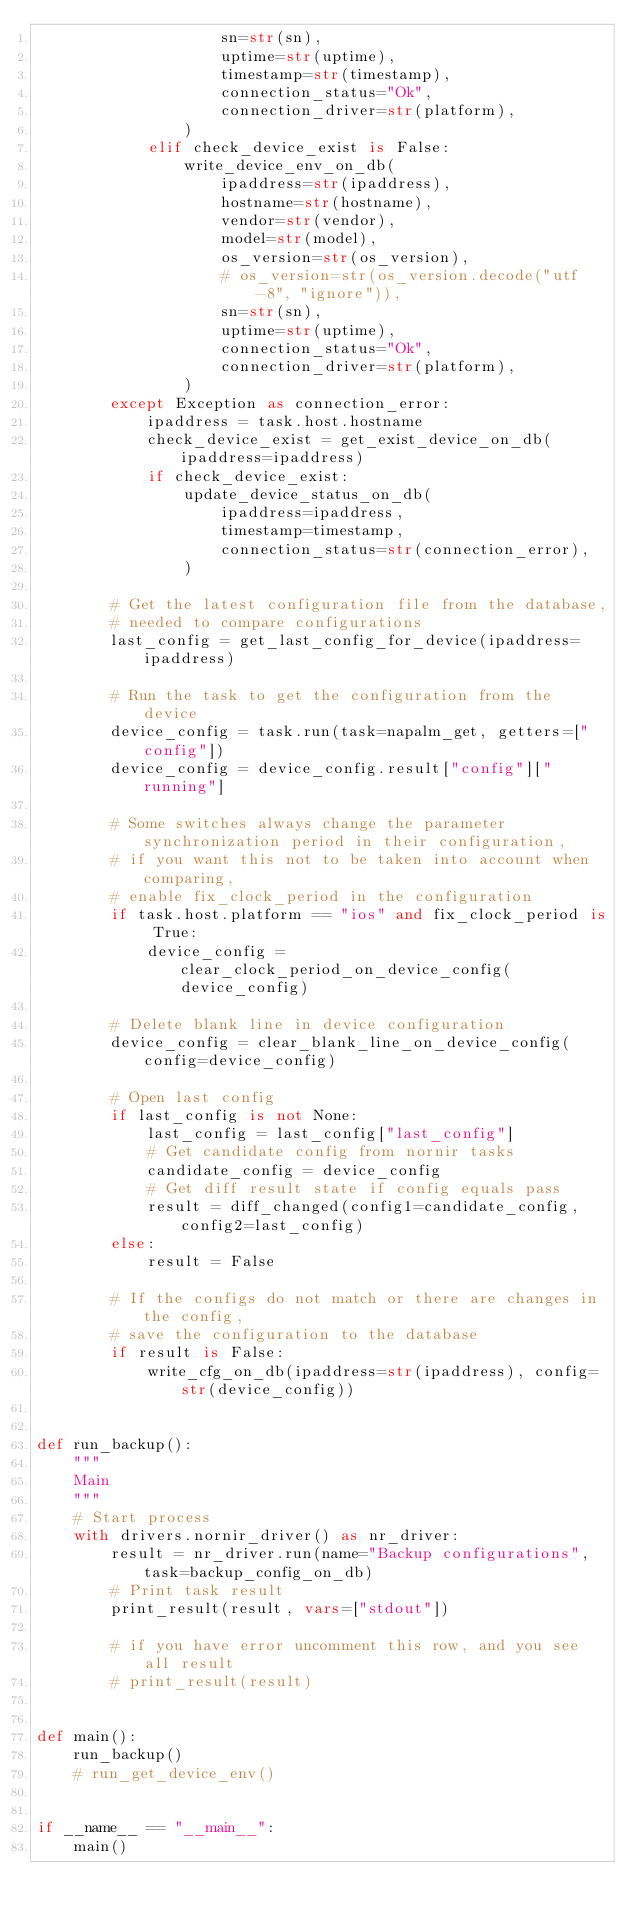Convert code to text. <code><loc_0><loc_0><loc_500><loc_500><_Python_>                    sn=str(sn),
                    uptime=str(uptime),
                    timestamp=str(timestamp),
                    connection_status="Ok",
                    connection_driver=str(platform),
                )
            elif check_device_exist is False:
                write_device_env_on_db(
                    ipaddress=str(ipaddress),
                    hostname=str(hostname),
                    vendor=str(vendor),
                    model=str(model),
                    os_version=str(os_version),
                    # os_version=str(os_version.decode("utf-8", "ignore")),
                    sn=str(sn),
                    uptime=str(uptime),
                    connection_status="Ok",
                    connection_driver=str(platform),
                )
        except Exception as connection_error:
            ipaddress = task.host.hostname
            check_device_exist = get_exist_device_on_db(ipaddress=ipaddress)
            if check_device_exist:
                update_device_status_on_db(
                    ipaddress=ipaddress,
                    timestamp=timestamp,
                    connection_status=str(connection_error),
                )

        # Get the latest configuration file from the database,
        # needed to compare configurations
        last_config = get_last_config_for_device(ipaddress=ipaddress)

        # Run the task to get the configuration from the device
        device_config = task.run(task=napalm_get, getters=["config"])
        device_config = device_config.result["config"]["running"]

        # Some switches always change the parameter synchronization period in their configuration,
        # if you want this not to be taken into account when comparing,
        # enable fix_clock_period in the configuration
        if task.host.platform == "ios" and fix_clock_period is True:
            device_config = clear_clock_period_on_device_config(device_config)

        # Delete blank line in device configuration
        device_config = clear_blank_line_on_device_config(config=device_config)

        # Open last config
        if last_config is not None:
            last_config = last_config["last_config"]
            # Get candidate config from nornir tasks
            candidate_config = device_config
            # Get diff result state if config equals pass
            result = diff_changed(config1=candidate_config, config2=last_config)
        else:
            result = False

        # If the configs do not match or there are changes in the config,
        # save the configuration to the database
        if result is False:
            write_cfg_on_db(ipaddress=str(ipaddress), config=str(device_config))


def run_backup():
    """
    Main
    """
    # Start process
    with drivers.nornir_driver() as nr_driver:
        result = nr_driver.run(name="Backup configurations", task=backup_config_on_db)
        # Print task result
        print_result(result, vars=["stdout"])

        # if you have error uncomment this row, and you see all result
        # print_result(result)


def main():
    run_backup()
    # run_get_device_env()


if __name__ == "__main__":
    main()
</code> 